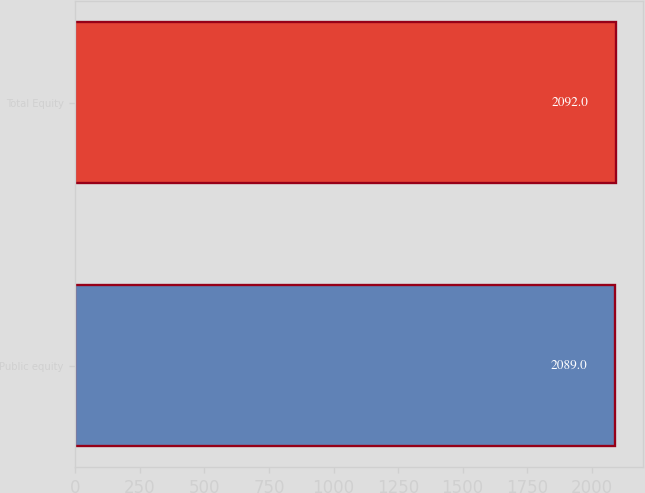<chart> <loc_0><loc_0><loc_500><loc_500><bar_chart><fcel>Public equity<fcel>Total Equity<nl><fcel>2089<fcel>2092<nl></chart> 